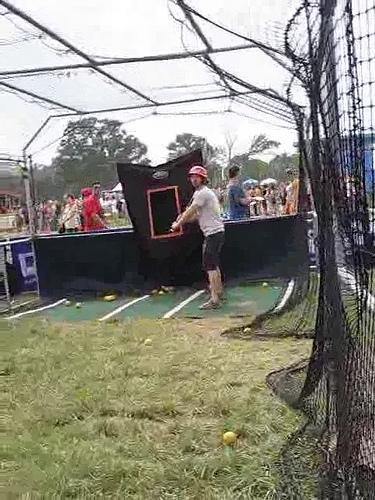What two surfaces are shown?
Write a very short answer. Grass and concrete. What is the man in the picture doing?
Answer briefly. Batting. What is the color of the balls on the ground?
Concise answer only. Yellow. 